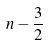<formula> <loc_0><loc_0><loc_500><loc_500>n - \frac { 3 } { 2 }</formula> 